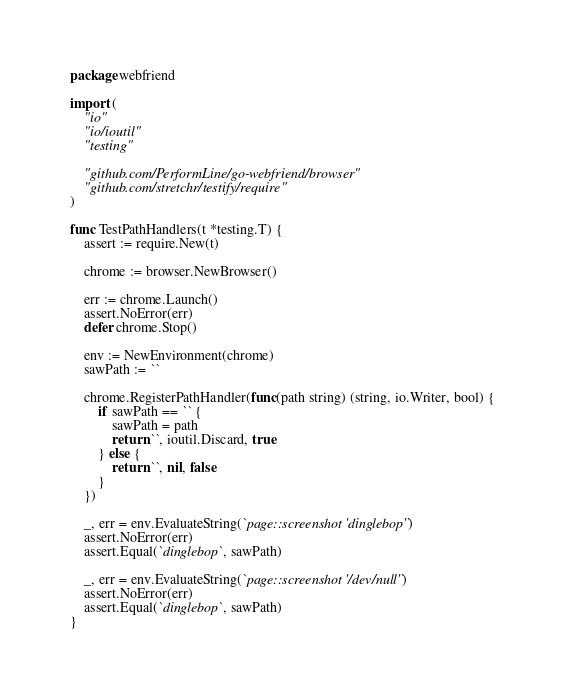<code> <loc_0><loc_0><loc_500><loc_500><_Go_>package webfriend

import (
	"io"
	"io/ioutil"
	"testing"

	"github.com/PerformLine/go-webfriend/browser"
	"github.com/stretchr/testify/require"
)

func TestPathHandlers(t *testing.T) {
	assert := require.New(t)

	chrome := browser.NewBrowser()

	err := chrome.Launch()
	assert.NoError(err)
	defer chrome.Stop()

	env := NewEnvironment(chrome)
	sawPath := ``

	chrome.RegisterPathHandler(func(path string) (string, io.Writer, bool) {
		if sawPath == `` {
			sawPath = path
			return ``, ioutil.Discard, true
		} else {
			return ``, nil, false
		}
	})

	_, err = env.EvaluateString(`page::screenshot 'dinglebop'`)
	assert.NoError(err)
	assert.Equal(`dinglebop`, sawPath)

	_, err = env.EvaluateString(`page::screenshot '/dev/null'`)
	assert.NoError(err)
	assert.Equal(`dinglebop`, sawPath)
}
</code> 